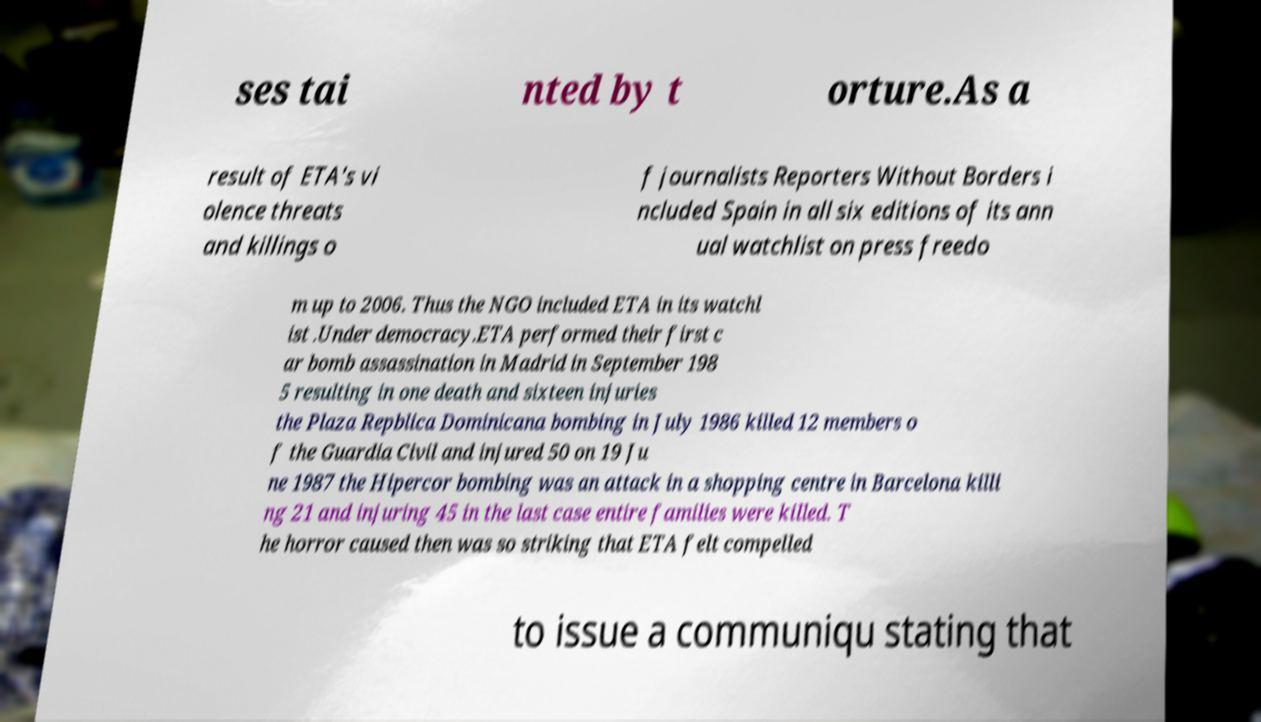Please read and relay the text visible in this image. What does it say? ses tai nted by t orture.As a result of ETA's vi olence threats and killings o f journalists Reporters Without Borders i ncluded Spain in all six editions of its ann ual watchlist on press freedo m up to 2006. Thus the NGO included ETA in its watchl ist .Under democracy.ETA performed their first c ar bomb assassination in Madrid in September 198 5 resulting in one death and sixteen injuries the Plaza Repblica Dominicana bombing in July 1986 killed 12 members o f the Guardia Civil and injured 50 on 19 Ju ne 1987 the Hipercor bombing was an attack in a shopping centre in Barcelona killi ng 21 and injuring 45 in the last case entire families were killed. T he horror caused then was so striking that ETA felt compelled to issue a communiqu stating that 